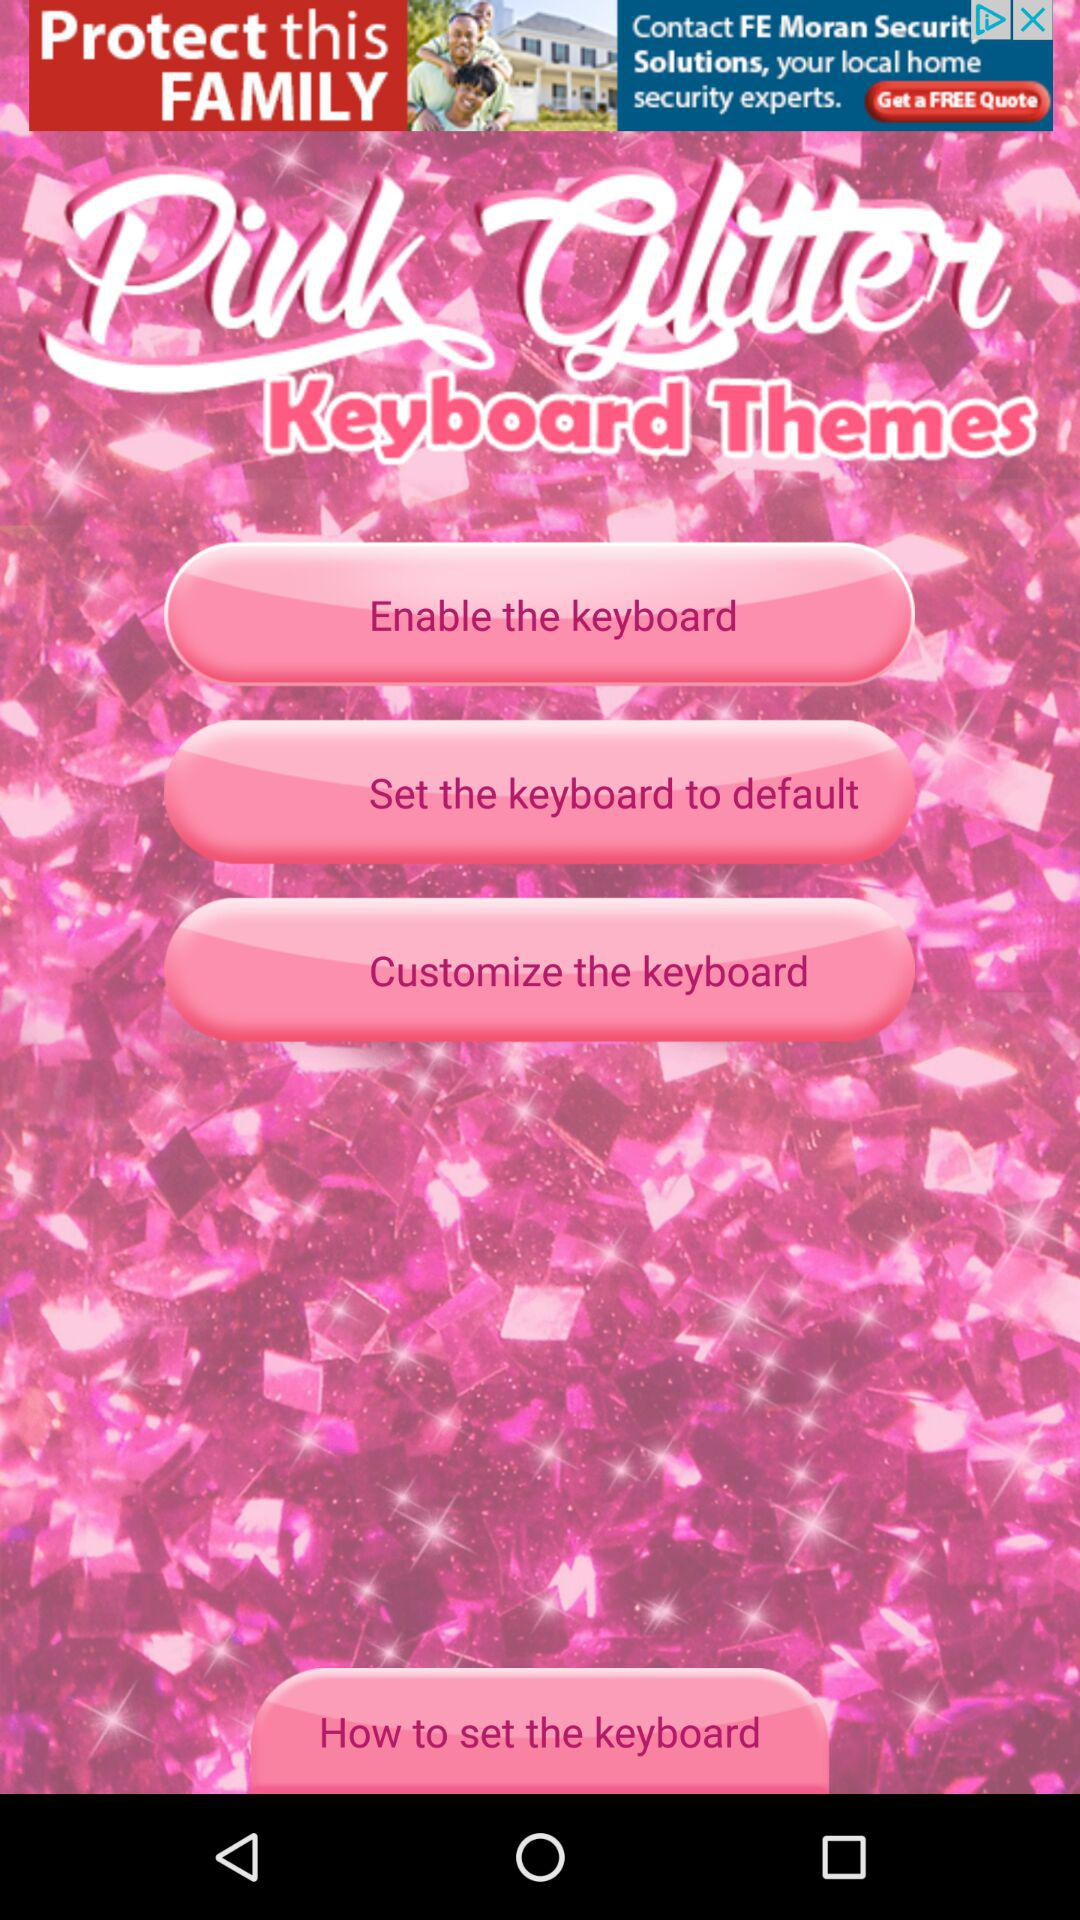What is the name of the application? The name of the application is "pink Glitter". 